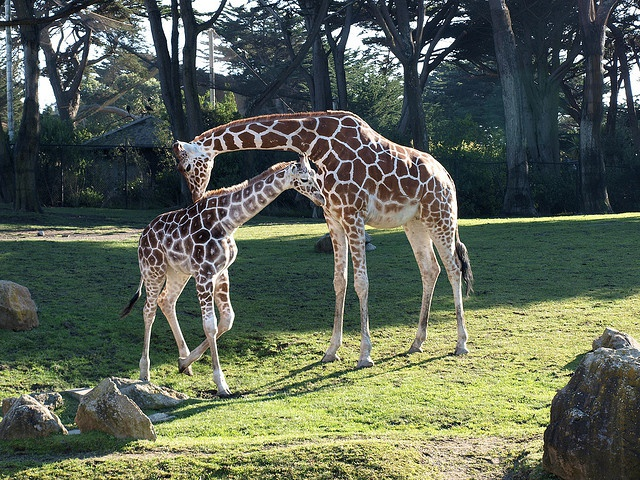Describe the objects in this image and their specific colors. I can see giraffe in black, darkgray, maroon, and gray tones and giraffe in black, darkgray, gray, and lightgray tones in this image. 